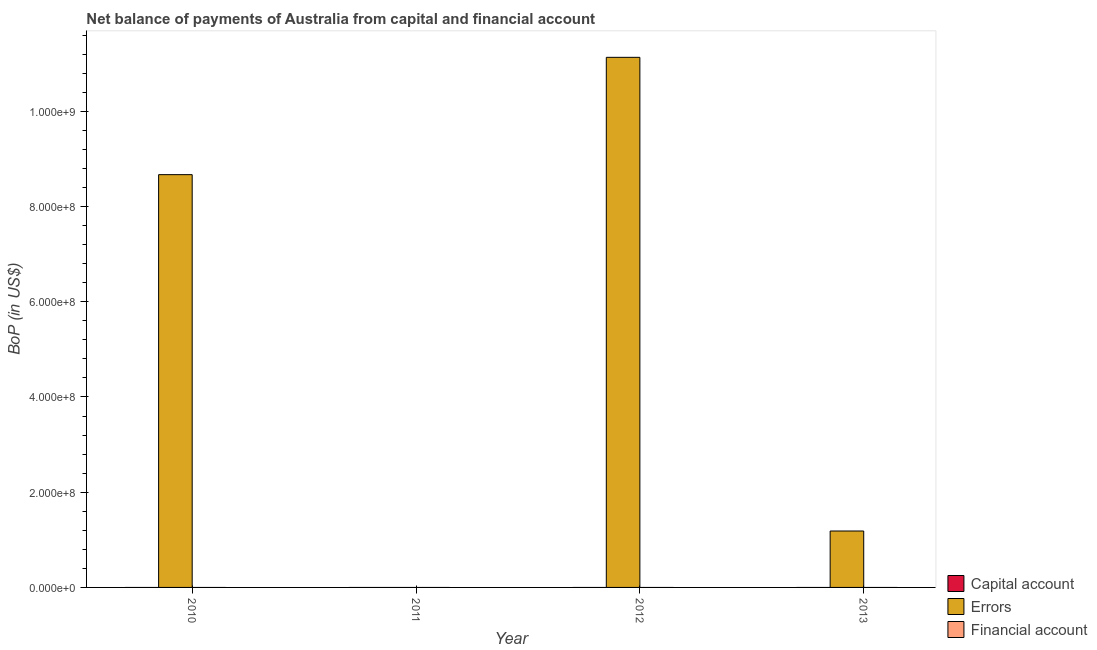How many different coloured bars are there?
Offer a very short reply. 1. Are the number of bars on each tick of the X-axis equal?
Your answer should be compact. No. How many bars are there on the 4th tick from the left?
Make the answer very short. 1. How many bars are there on the 2nd tick from the right?
Make the answer very short. 1. What is the label of the 3rd group of bars from the left?
Provide a succinct answer. 2012. What is the amount of net capital account in 2011?
Give a very brief answer. 0. Across all years, what is the maximum amount of errors?
Your answer should be very brief. 1.11e+09. Across all years, what is the minimum amount of errors?
Offer a very short reply. 0. What is the total amount of errors in the graph?
Keep it short and to the point. 2.10e+09. What is the difference between the amount of errors in 2010 and that in 2013?
Give a very brief answer. 7.48e+08. What is the average amount of errors per year?
Your answer should be very brief. 5.25e+08. In the year 2012, what is the difference between the amount of errors and amount of financial account?
Provide a short and direct response. 0. In how many years, is the amount of net capital account greater than 960000000 US$?
Provide a succinct answer. 0. What is the ratio of the amount of errors in 2010 to that in 2012?
Make the answer very short. 0.78. Is the amount of errors in 2010 less than that in 2012?
Make the answer very short. Yes. What is the difference between the highest and the second highest amount of errors?
Offer a very short reply. 2.46e+08. What is the difference between the highest and the lowest amount of errors?
Offer a terse response. 1.11e+09. Is it the case that in every year, the sum of the amount of net capital account and amount of errors is greater than the amount of financial account?
Give a very brief answer. No. What is the difference between two consecutive major ticks on the Y-axis?
Your answer should be very brief. 2.00e+08. Does the graph contain grids?
Keep it short and to the point. No. Where does the legend appear in the graph?
Your answer should be very brief. Bottom right. How many legend labels are there?
Give a very brief answer. 3. How are the legend labels stacked?
Provide a succinct answer. Vertical. What is the title of the graph?
Offer a very short reply. Net balance of payments of Australia from capital and financial account. Does "Czech Republic" appear as one of the legend labels in the graph?
Offer a very short reply. No. What is the label or title of the Y-axis?
Offer a terse response. BoP (in US$). What is the BoP (in US$) of Capital account in 2010?
Ensure brevity in your answer.  0. What is the BoP (in US$) of Errors in 2010?
Provide a short and direct response. 8.67e+08. What is the BoP (in US$) in Errors in 2012?
Make the answer very short. 1.11e+09. What is the BoP (in US$) in Financial account in 2012?
Give a very brief answer. 0. What is the BoP (in US$) in Errors in 2013?
Give a very brief answer. 1.18e+08. Across all years, what is the maximum BoP (in US$) in Errors?
Keep it short and to the point. 1.11e+09. Across all years, what is the minimum BoP (in US$) of Errors?
Offer a very short reply. 0. What is the total BoP (in US$) of Capital account in the graph?
Your response must be concise. 0. What is the total BoP (in US$) in Errors in the graph?
Offer a very short reply. 2.10e+09. What is the total BoP (in US$) of Financial account in the graph?
Make the answer very short. 0. What is the difference between the BoP (in US$) in Errors in 2010 and that in 2012?
Make the answer very short. -2.46e+08. What is the difference between the BoP (in US$) of Errors in 2010 and that in 2013?
Your response must be concise. 7.48e+08. What is the difference between the BoP (in US$) of Errors in 2012 and that in 2013?
Your answer should be compact. 9.95e+08. What is the average BoP (in US$) in Errors per year?
Ensure brevity in your answer.  5.25e+08. What is the average BoP (in US$) in Financial account per year?
Offer a terse response. 0. What is the ratio of the BoP (in US$) of Errors in 2010 to that in 2012?
Provide a short and direct response. 0.78. What is the ratio of the BoP (in US$) in Errors in 2010 to that in 2013?
Offer a terse response. 7.32. What is the ratio of the BoP (in US$) in Errors in 2012 to that in 2013?
Offer a very short reply. 9.4. What is the difference between the highest and the second highest BoP (in US$) of Errors?
Make the answer very short. 2.46e+08. What is the difference between the highest and the lowest BoP (in US$) of Errors?
Your answer should be compact. 1.11e+09. 